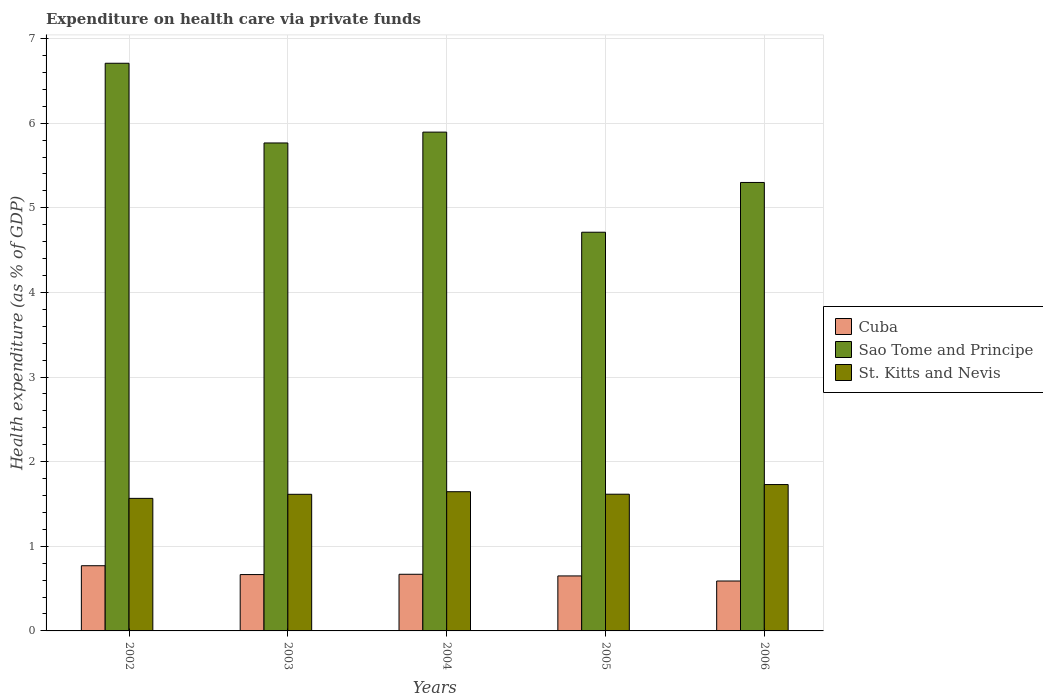How many different coloured bars are there?
Offer a very short reply. 3. How many groups of bars are there?
Your response must be concise. 5. Are the number of bars on each tick of the X-axis equal?
Ensure brevity in your answer.  Yes. What is the label of the 4th group of bars from the left?
Ensure brevity in your answer.  2005. What is the expenditure made on health care in Cuba in 2004?
Give a very brief answer. 0.67. Across all years, what is the maximum expenditure made on health care in Sao Tome and Principe?
Provide a succinct answer. 6.71. Across all years, what is the minimum expenditure made on health care in Sao Tome and Principe?
Your answer should be very brief. 4.71. What is the total expenditure made on health care in Sao Tome and Principe in the graph?
Offer a terse response. 28.38. What is the difference between the expenditure made on health care in St. Kitts and Nevis in 2004 and that in 2006?
Make the answer very short. -0.08. What is the difference between the expenditure made on health care in St. Kitts and Nevis in 2003 and the expenditure made on health care in Sao Tome and Principe in 2002?
Provide a short and direct response. -5.09. What is the average expenditure made on health care in Cuba per year?
Your answer should be compact. 0.67. In the year 2002, what is the difference between the expenditure made on health care in Cuba and expenditure made on health care in Sao Tome and Principe?
Ensure brevity in your answer.  -5.94. In how many years, is the expenditure made on health care in Cuba greater than 5.2 %?
Provide a short and direct response. 0. What is the ratio of the expenditure made on health care in Cuba in 2002 to that in 2006?
Give a very brief answer. 1.31. Is the difference between the expenditure made on health care in Cuba in 2005 and 2006 greater than the difference between the expenditure made on health care in Sao Tome and Principe in 2005 and 2006?
Your answer should be compact. Yes. What is the difference between the highest and the second highest expenditure made on health care in St. Kitts and Nevis?
Keep it short and to the point. 0.08. What is the difference between the highest and the lowest expenditure made on health care in Sao Tome and Principe?
Offer a terse response. 2. In how many years, is the expenditure made on health care in Cuba greater than the average expenditure made on health care in Cuba taken over all years?
Ensure brevity in your answer.  2. What does the 3rd bar from the left in 2003 represents?
Provide a short and direct response. St. Kitts and Nevis. What does the 2nd bar from the right in 2004 represents?
Ensure brevity in your answer.  Sao Tome and Principe. What is the difference between two consecutive major ticks on the Y-axis?
Offer a very short reply. 1. Where does the legend appear in the graph?
Offer a very short reply. Center right. What is the title of the graph?
Offer a very short reply. Expenditure on health care via private funds. Does "Sao Tome and Principe" appear as one of the legend labels in the graph?
Provide a short and direct response. Yes. What is the label or title of the Y-axis?
Provide a short and direct response. Health expenditure (as % of GDP). What is the Health expenditure (as % of GDP) in Cuba in 2002?
Your answer should be compact. 0.77. What is the Health expenditure (as % of GDP) in Sao Tome and Principe in 2002?
Your answer should be very brief. 6.71. What is the Health expenditure (as % of GDP) in St. Kitts and Nevis in 2002?
Give a very brief answer. 1.57. What is the Health expenditure (as % of GDP) in Cuba in 2003?
Ensure brevity in your answer.  0.67. What is the Health expenditure (as % of GDP) in Sao Tome and Principe in 2003?
Your response must be concise. 5.77. What is the Health expenditure (as % of GDP) in St. Kitts and Nevis in 2003?
Your response must be concise. 1.61. What is the Health expenditure (as % of GDP) in Cuba in 2004?
Your answer should be very brief. 0.67. What is the Health expenditure (as % of GDP) in Sao Tome and Principe in 2004?
Offer a terse response. 5.89. What is the Health expenditure (as % of GDP) in St. Kitts and Nevis in 2004?
Make the answer very short. 1.65. What is the Health expenditure (as % of GDP) in Cuba in 2005?
Your response must be concise. 0.65. What is the Health expenditure (as % of GDP) in Sao Tome and Principe in 2005?
Provide a short and direct response. 4.71. What is the Health expenditure (as % of GDP) of St. Kitts and Nevis in 2005?
Provide a succinct answer. 1.62. What is the Health expenditure (as % of GDP) in Cuba in 2006?
Keep it short and to the point. 0.59. What is the Health expenditure (as % of GDP) in Sao Tome and Principe in 2006?
Ensure brevity in your answer.  5.3. What is the Health expenditure (as % of GDP) in St. Kitts and Nevis in 2006?
Your answer should be compact. 1.73. Across all years, what is the maximum Health expenditure (as % of GDP) in Cuba?
Offer a very short reply. 0.77. Across all years, what is the maximum Health expenditure (as % of GDP) of Sao Tome and Principe?
Provide a succinct answer. 6.71. Across all years, what is the maximum Health expenditure (as % of GDP) of St. Kitts and Nevis?
Keep it short and to the point. 1.73. Across all years, what is the minimum Health expenditure (as % of GDP) in Cuba?
Your answer should be compact. 0.59. Across all years, what is the minimum Health expenditure (as % of GDP) in Sao Tome and Principe?
Offer a terse response. 4.71. Across all years, what is the minimum Health expenditure (as % of GDP) of St. Kitts and Nevis?
Your response must be concise. 1.57. What is the total Health expenditure (as % of GDP) of Cuba in the graph?
Give a very brief answer. 3.35. What is the total Health expenditure (as % of GDP) in Sao Tome and Principe in the graph?
Your response must be concise. 28.38. What is the total Health expenditure (as % of GDP) in St. Kitts and Nevis in the graph?
Give a very brief answer. 8.17. What is the difference between the Health expenditure (as % of GDP) in Cuba in 2002 and that in 2003?
Offer a very short reply. 0.1. What is the difference between the Health expenditure (as % of GDP) in Sao Tome and Principe in 2002 and that in 2003?
Ensure brevity in your answer.  0.94. What is the difference between the Health expenditure (as % of GDP) of St. Kitts and Nevis in 2002 and that in 2003?
Your answer should be compact. -0.05. What is the difference between the Health expenditure (as % of GDP) in Cuba in 2002 and that in 2004?
Provide a succinct answer. 0.1. What is the difference between the Health expenditure (as % of GDP) in Sao Tome and Principe in 2002 and that in 2004?
Provide a short and direct response. 0.81. What is the difference between the Health expenditure (as % of GDP) in St. Kitts and Nevis in 2002 and that in 2004?
Your response must be concise. -0.08. What is the difference between the Health expenditure (as % of GDP) in Cuba in 2002 and that in 2005?
Your response must be concise. 0.12. What is the difference between the Health expenditure (as % of GDP) of Sao Tome and Principe in 2002 and that in 2005?
Offer a terse response. 2. What is the difference between the Health expenditure (as % of GDP) in St. Kitts and Nevis in 2002 and that in 2005?
Offer a very short reply. -0.05. What is the difference between the Health expenditure (as % of GDP) in Cuba in 2002 and that in 2006?
Offer a terse response. 0.18. What is the difference between the Health expenditure (as % of GDP) in Sao Tome and Principe in 2002 and that in 2006?
Your response must be concise. 1.41. What is the difference between the Health expenditure (as % of GDP) of St. Kitts and Nevis in 2002 and that in 2006?
Make the answer very short. -0.16. What is the difference between the Health expenditure (as % of GDP) of Cuba in 2003 and that in 2004?
Your answer should be compact. -0. What is the difference between the Health expenditure (as % of GDP) of Sao Tome and Principe in 2003 and that in 2004?
Your answer should be compact. -0.13. What is the difference between the Health expenditure (as % of GDP) of St. Kitts and Nevis in 2003 and that in 2004?
Your answer should be very brief. -0.03. What is the difference between the Health expenditure (as % of GDP) of Cuba in 2003 and that in 2005?
Keep it short and to the point. 0.02. What is the difference between the Health expenditure (as % of GDP) in Sao Tome and Principe in 2003 and that in 2005?
Provide a short and direct response. 1.05. What is the difference between the Health expenditure (as % of GDP) in St. Kitts and Nevis in 2003 and that in 2005?
Offer a very short reply. -0. What is the difference between the Health expenditure (as % of GDP) in Cuba in 2003 and that in 2006?
Provide a succinct answer. 0.08. What is the difference between the Health expenditure (as % of GDP) of Sao Tome and Principe in 2003 and that in 2006?
Make the answer very short. 0.47. What is the difference between the Health expenditure (as % of GDP) in St. Kitts and Nevis in 2003 and that in 2006?
Your answer should be compact. -0.12. What is the difference between the Health expenditure (as % of GDP) in Cuba in 2004 and that in 2005?
Provide a succinct answer. 0.02. What is the difference between the Health expenditure (as % of GDP) in Sao Tome and Principe in 2004 and that in 2005?
Offer a very short reply. 1.18. What is the difference between the Health expenditure (as % of GDP) in St. Kitts and Nevis in 2004 and that in 2005?
Your answer should be compact. 0.03. What is the difference between the Health expenditure (as % of GDP) of Cuba in 2004 and that in 2006?
Keep it short and to the point. 0.08. What is the difference between the Health expenditure (as % of GDP) in Sao Tome and Principe in 2004 and that in 2006?
Offer a very short reply. 0.59. What is the difference between the Health expenditure (as % of GDP) in St. Kitts and Nevis in 2004 and that in 2006?
Provide a short and direct response. -0.08. What is the difference between the Health expenditure (as % of GDP) in Cuba in 2005 and that in 2006?
Your answer should be very brief. 0.06. What is the difference between the Health expenditure (as % of GDP) in Sao Tome and Principe in 2005 and that in 2006?
Ensure brevity in your answer.  -0.59. What is the difference between the Health expenditure (as % of GDP) in St. Kitts and Nevis in 2005 and that in 2006?
Your answer should be very brief. -0.11. What is the difference between the Health expenditure (as % of GDP) of Cuba in 2002 and the Health expenditure (as % of GDP) of Sao Tome and Principe in 2003?
Give a very brief answer. -5. What is the difference between the Health expenditure (as % of GDP) of Cuba in 2002 and the Health expenditure (as % of GDP) of St. Kitts and Nevis in 2003?
Give a very brief answer. -0.84. What is the difference between the Health expenditure (as % of GDP) of Sao Tome and Principe in 2002 and the Health expenditure (as % of GDP) of St. Kitts and Nevis in 2003?
Offer a very short reply. 5.09. What is the difference between the Health expenditure (as % of GDP) of Cuba in 2002 and the Health expenditure (as % of GDP) of Sao Tome and Principe in 2004?
Offer a very short reply. -5.12. What is the difference between the Health expenditure (as % of GDP) of Cuba in 2002 and the Health expenditure (as % of GDP) of St. Kitts and Nevis in 2004?
Offer a terse response. -0.87. What is the difference between the Health expenditure (as % of GDP) in Sao Tome and Principe in 2002 and the Health expenditure (as % of GDP) in St. Kitts and Nevis in 2004?
Your response must be concise. 5.06. What is the difference between the Health expenditure (as % of GDP) in Cuba in 2002 and the Health expenditure (as % of GDP) in Sao Tome and Principe in 2005?
Your response must be concise. -3.94. What is the difference between the Health expenditure (as % of GDP) of Cuba in 2002 and the Health expenditure (as % of GDP) of St. Kitts and Nevis in 2005?
Your answer should be compact. -0.85. What is the difference between the Health expenditure (as % of GDP) of Sao Tome and Principe in 2002 and the Health expenditure (as % of GDP) of St. Kitts and Nevis in 2005?
Offer a very short reply. 5.09. What is the difference between the Health expenditure (as % of GDP) of Cuba in 2002 and the Health expenditure (as % of GDP) of Sao Tome and Principe in 2006?
Your response must be concise. -4.53. What is the difference between the Health expenditure (as % of GDP) in Cuba in 2002 and the Health expenditure (as % of GDP) in St. Kitts and Nevis in 2006?
Your answer should be very brief. -0.96. What is the difference between the Health expenditure (as % of GDP) in Sao Tome and Principe in 2002 and the Health expenditure (as % of GDP) in St. Kitts and Nevis in 2006?
Offer a terse response. 4.98. What is the difference between the Health expenditure (as % of GDP) of Cuba in 2003 and the Health expenditure (as % of GDP) of Sao Tome and Principe in 2004?
Provide a short and direct response. -5.23. What is the difference between the Health expenditure (as % of GDP) in Cuba in 2003 and the Health expenditure (as % of GDP) in St. Kitts and Nevis in 2004?
Make the answer very short. -0.98. What is the difference between the Health expenditure (as % of GDP) in Sao Tome and Principe in 2003 and the Health expenditure (as % of GDP) in St. Kitts and Nevis in 2004?
Your answer should be very brief. 4.12. What is the difference between the Health expenditure (as % of GDP) in Cuba in 2003 and the Health expenditure (as % of GDP) in Sao Tome and Principe in 2005?
Your answer should be very brief. -4.05. What is the difference between the Health expenditure (as % of GDP) in Cuba in 2003 and the Health expenditure (as % of GDP) in St. Kitts and Nevis in 2005?
Give a very brief answer. -0.95. What is the difference between the Health expenditure (as % of GDP) in Sao Tome and Principe in 2003 and the Health expenditure (as % of GDP) in St. Kitts and Nevis in 2005?
Ensure brevity in your answer.  4.15. What is the difference between the Health expenditure (as % of GDP) in Cuba in 2003 and the Health expenditure (as % of GDP) in Sao Tome and Principe in 2006?
Your answer should be very brief. -4.63. What is the difference between the Health expenditure (as % of GDP) in Cuba in 2003 and the Health expenditure (as % of GDP) in St. Kitts and Nevis in 2006?
Keep it short and to the point. -1.06. What is the difference between the Health expenditure (as % of GDP) in Sao Tome and Principe in 2003 and the Health expenditure (as % of GDP) in St. Kitts and Nevis in 2006?
Your answer should be compact. 4.04. What is the difference between the Health expenditure (as % of GDP) of Cuba in 2004 and the Health expenditure (as % of GDP) of Sao Tome and Principe in 2005?
Make the answer very short. -4.04. What is the difference between the Health expenditure (as % of GDP) in Cuba in 2004 and the Health expenditure (as % of GDP) in St. Kitts and Nevis in 2005?
Keep it short and to the point. -0.95. What is the difference between the Health expenditure (as % of GDP) of Sao Tome and Principe in 2004 and the Health expenditure (as % of GDP) of St. Kitts and Nevis in 2005?
Offer a terse response. 4.28. What is the difference between the Health expenditure (as % of GDP) of Cuba in 2004 and the Health expenditure (as % of GDP) of Sao Tome and Principe in 2006?
Offer a very short reply. -4.63. What is the difference between the Health expenditure (as % of GDP) in Cuba in 2004 and the Health expenditure (as % of GDP) in St. Kitts and Nevis in 2006?
Offer a very short reply. -1.06. What is the difference between the Health expenditure (as % of GDP) in Sao Tome and Principe in 2004 and the Health expenditure (as % of GDP) in St. Kitts and Nevis in 2006?
Offer a very short reply. 4.16. What is the difference between the Health expenditure (as % of GDP) in Cuba in 2005 and the Health expenditure (as % of GDP) in Sao Tome and Principe in 2006?
Ensure brevity in your answer.  -4.65. What is the difference between the Health expenditure (as % of GDP) of Cuba in 2005 and the Health expenditure (as % of GDP) of St. Kitts and Nevis in 2006?
Your response must be concise. -1.08. What is the difference between the Health expenditure (as % of GDP) in Sao Tome and Principe in 2005 and the Health expenditure (as % of GDP) in St. Kitts and Nevis in 2006?
Offer a terse response. 2.98. What is the average Health expenditure (as % of GDP) in Cuba per year?
Your answer should be compact. 0.67. What is the average Health expenditure (as % of GDP) in Sao Tome and Principe per year?
Keep it short and to the point. 5.68. What is the average Health expenditure (as % of GDP) in St. Kitts and Nevis per year?
Your answer should be very brief. 1.63. In the year 2002, what is the difference between the Health expenditure (as % of GDP) of Cuba and Health expenditure (as % of GDP) of Sao Tome and Principe?
Ensure brevity in your answer.  -5.94. In the year 2002, what is the difference between the Health expenditure (as % of GDP) of Cuba and Health expenditure (as % of GDP) of St. Kitts and Nevis?
Your answer should be very brief. -0.8. In the year 2002, what is the difference between the Health expenditure (as % of GDP) of Sao Tome and Principe and Health expenditure (as % of GDP) of St. Kitts and Nevis?
Give a very brief answer. 5.14. In the year 2003, what is the difference between the Health expenditure (as % of GDP) of Cuba and Health expenditure (as % of GDP) of Sao Tome and Principe?
Keep it short and to the point. -5.1. In the year 2003, what is the difference between the Health expenditure (as % of GDP) in Cuba and Health expenditure (as % of GDP) in St. Kitts and Nevis?
Your answer should be compact. -0.95. In the year 2003, what is the difference between the Health expenditure (as % of GDP) in Sao Tome and Principe and Health expenditure (as % of GDP) in St. Kitts and Nevis?
Offer a terse response. 4.15. In the year 2004, what is the difference between the Health expenditure (as % of GDP) of Cuba and Health expenditure (as % of GDP) of Sao Tome and Principe?
Provide a succinct answer. -5.23. In the year 2004, what is the difference between the Health expenditure (as % of GDP) in Cuba and Health expenditure (as % of GDP) in St. Kitts and Nevis?
Ensure brevity in your answer.  -0.98. In the year 2004, what is the difference between the Health expenditure (as % of GDP) of Sao Tome and Principe and Health expenditure (as % of GDP) of St. Kitts and Nevis?
Offer a terse response. 4.25. In the year 2005, what is the difference between the Health expenditure (as % of GDP) in Cuba and Health expenditure (as % of GDP) in Sao Tome and Principe?
Your answer should be compact. -4.06. In the year 2005, what is the difference between the Health expenditure (as % of GDP) of Cuba and Health expenditure (as % of GDP) of St. Kitts and Nevis?
Ensure brevity in your answer.  -0.97. In the year 2005, what is the difference between the Health expenditure (as % of GDP) in Sao Tome and Principe and Health expenditure (as % of GDP) in St. Kitts and Nevis?
Your answer should be compact. 3.1. In the year 2006, what is the difference between the Health expenditure (as % of GDP) of Cuba and Health expenditure (as % of GDP) of Sao Tome and Principe?
Provide a succinct answer. -4.71. In the year 2006, what is the difference between the Health expenditure (as % of GDP) of Cuba and Health expenditure (as % of GDP) of St. Kitts and Nevis?
Provide a succinct answer. -1.14. In the year 2006, what is the difference between the Health expenditure (as % of GDP) of Sao Tome and Principe and Health expenditure (as % of GDP) of St. Kitts and Nevis?
Make the answer very short. 3.57. What is the ratio of the Health expenditure (as % of GDP) of Cuba in 2002 to that in 2003?
Keep it short and to the point. 1.16. What is the ratio of the Health expenditure (as % of GDP) of Sao Tome and Principe in 2002 to that in 2003?
Offer a terse response. 1.16. What is the ratio of the Health expenditure (as % of GDP) of St. Kitts and Nevis in 2002 to that in 2003?
Your answer should be compact. 0.97. What is the ratio of the Health expenditure (as % of GDP) of Cuba in 2002 to that in 2004?
Provide a short and direct response. 1.15. What is the ratio of the Health expenditure (as % of GDP) of Sao Tome and Principe in 2002 to that in 2004?
Provide a short and direct response. 1.14. What is the ratio of the Health expenditure (as % of GDP) of St. Kitts and Nevis in 2002 to that in 2004?
Provide a succinct answer. 0.95. What is the ratio of the Health expenditure (as % of GDP) in Cuba in 2002 to that in 2005?
Your answer should be compact. 1.19. What is the ratio of the Health expenditure (as % of GDP) of Sao Tome and Principe in 2002 to that in 2005?
Your answer should be very brief. 1.42. What is the ratio of the Health expenditure (as % of GDP) in St. Kitts and Nevis in 2002 to that in 2005?
Ensure brevity in your answer.  0.97. What is the ratio of the Health expenditure (as % of GDP) in Cuba in 2002 to that in 2006?
Provide a succinct answer. 1.31. What is the ratio of the Health expenditure (as % of GDP) of Sao Tome and Principe in 2002 to that in 2006?
Keep it short and to the point. 1.27. What is the ratio of the Health expenditure (as % of GDP) in St. Kitts and Nevis in 2002 to that in 2006?
Your response must be concise. 0.91. What is the ratio of the Health expenditure (as % of GDP) of Cuba in 2003 to that in 2004?
Keep it short and to the point. 0.99. What is the ratio of the Health expenditure (as % of GDP) of Sao Tome and Principe in 2003 to that in 2004?
Provide a short and direct response. 0.98. What is the ratio of the Health expenditure (as % of GDP) of St. Kitts and Nevis in 2003 to that in 2004?
Give a very brief answer. 0.98. What is the ratio of the Health expenditure (as % of GDP) of Cuba in 2003 to that in 2005?
Offer a very short reply. 1.02. What is the ratio of the Health expenditure (as % of GDP) of Sao Tome and Principe in 2003 to that in 2005?
Your response must be concise. 1.22. What is the ratio of the Health expenditure (as % of GDP) in Cuba in 2003 to that in 2006?
Offer a very short reply. 1.13. What is the ratio of the Health expenditure (as % of GDP) in Sao Tome and Principe in 2003 to that in 2006?
Make the answer very short. 1.09. What is the ratio of the Health expenditure (as % of GDP) of St. Kitts and Nevis in 2003 to that in 2006?
Offer a very short reply. 0.93. What is the ratio of the Health expenditure (as % of GDP) of Cuba in 2004 to that in 2005?
Provide a succinct answer. 1.03. What is the ratio of the Health expenditure (as % of GDP) in Sao Tome and Principe in 2004 to that in 2005?
Offer a very short reply. 1.25. What is the ratio of the Health expenditure (as % of GDP) of St. Kitts and Nevis in 2004 to that in 2005?
Make the answer very short. 1.02. What is the ratio of the Health expenditure (as % of GDP) of Cuba in 2004 to that in 2006?
Your answer should be compact. 1.13. What is the ratio of the Health expenditure (as % of GDP) in Sao Tome and Principe in 2004 to that in 2006?
Keep it short and to the point. 1.11. What is the ratio of the Health expenditure (as % of GDP) of St. Kitts and Nevis in 2004 to that in 2006?
Offer a very short reply. 0.95. What is the ratio of the Health expenditure (as % of GDP) of Cuba in 2005 to that in 2006?
Your answer should be compact. 1.1. What is the ratio of the Health expenditure (as % of GDP) in Sao Tome and Principe in 2005 to that in 2006?
Offer a very short reply. 0.89. What is the ratio of the Health expenditure (as % of GDP) of St. Kitts and Nevis in 2005 to that in 2006?
Keep it short and to the point. 0.93. What is the difference between the highest and the second highest Health expenditure (as % of GDP) in Cuba?
Offer a terse response. 0.1. What is the difference between the highest and the second highest Health expenditure (as % of GDP) of Sao Tome and Principe?
Offer a terse response. 0.81. What is the difference between the highest and the second highest Health expenditure (as % of GDP) in St. Kitts and Nevis?
Provide a succinct answer. 0.08. What is the difference between the highest and the lowest Health expenditure (as % of GDP) of Cuba?
Make the answer very short. 0.18. What is the difference between the highest and the lowest Health expenditure (as % of GDP) of Sao Tome and Principe?
Ensure brevity in your answer.  2. What is the difference between the highest and the lowest Health expenditure (as % of GDP) of St. Kitts and Nevis?
Provide a succinct answer. 0.16. 